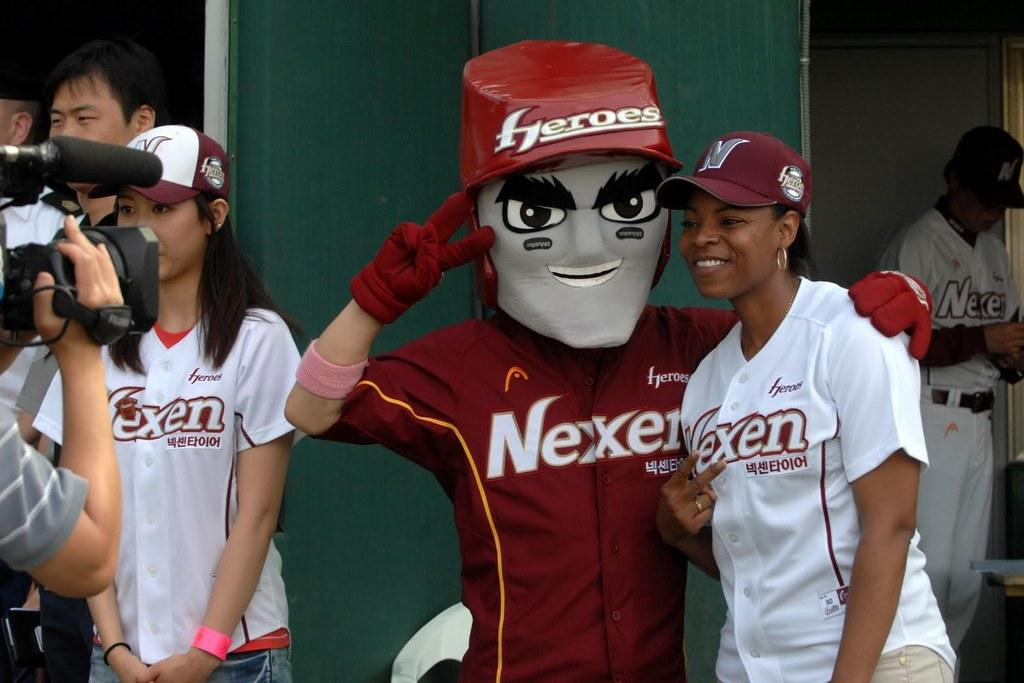<image>
Summarize the visual content of the image. People are posing with a Nexen Mascot dressed in red costume and a gray face mask. 